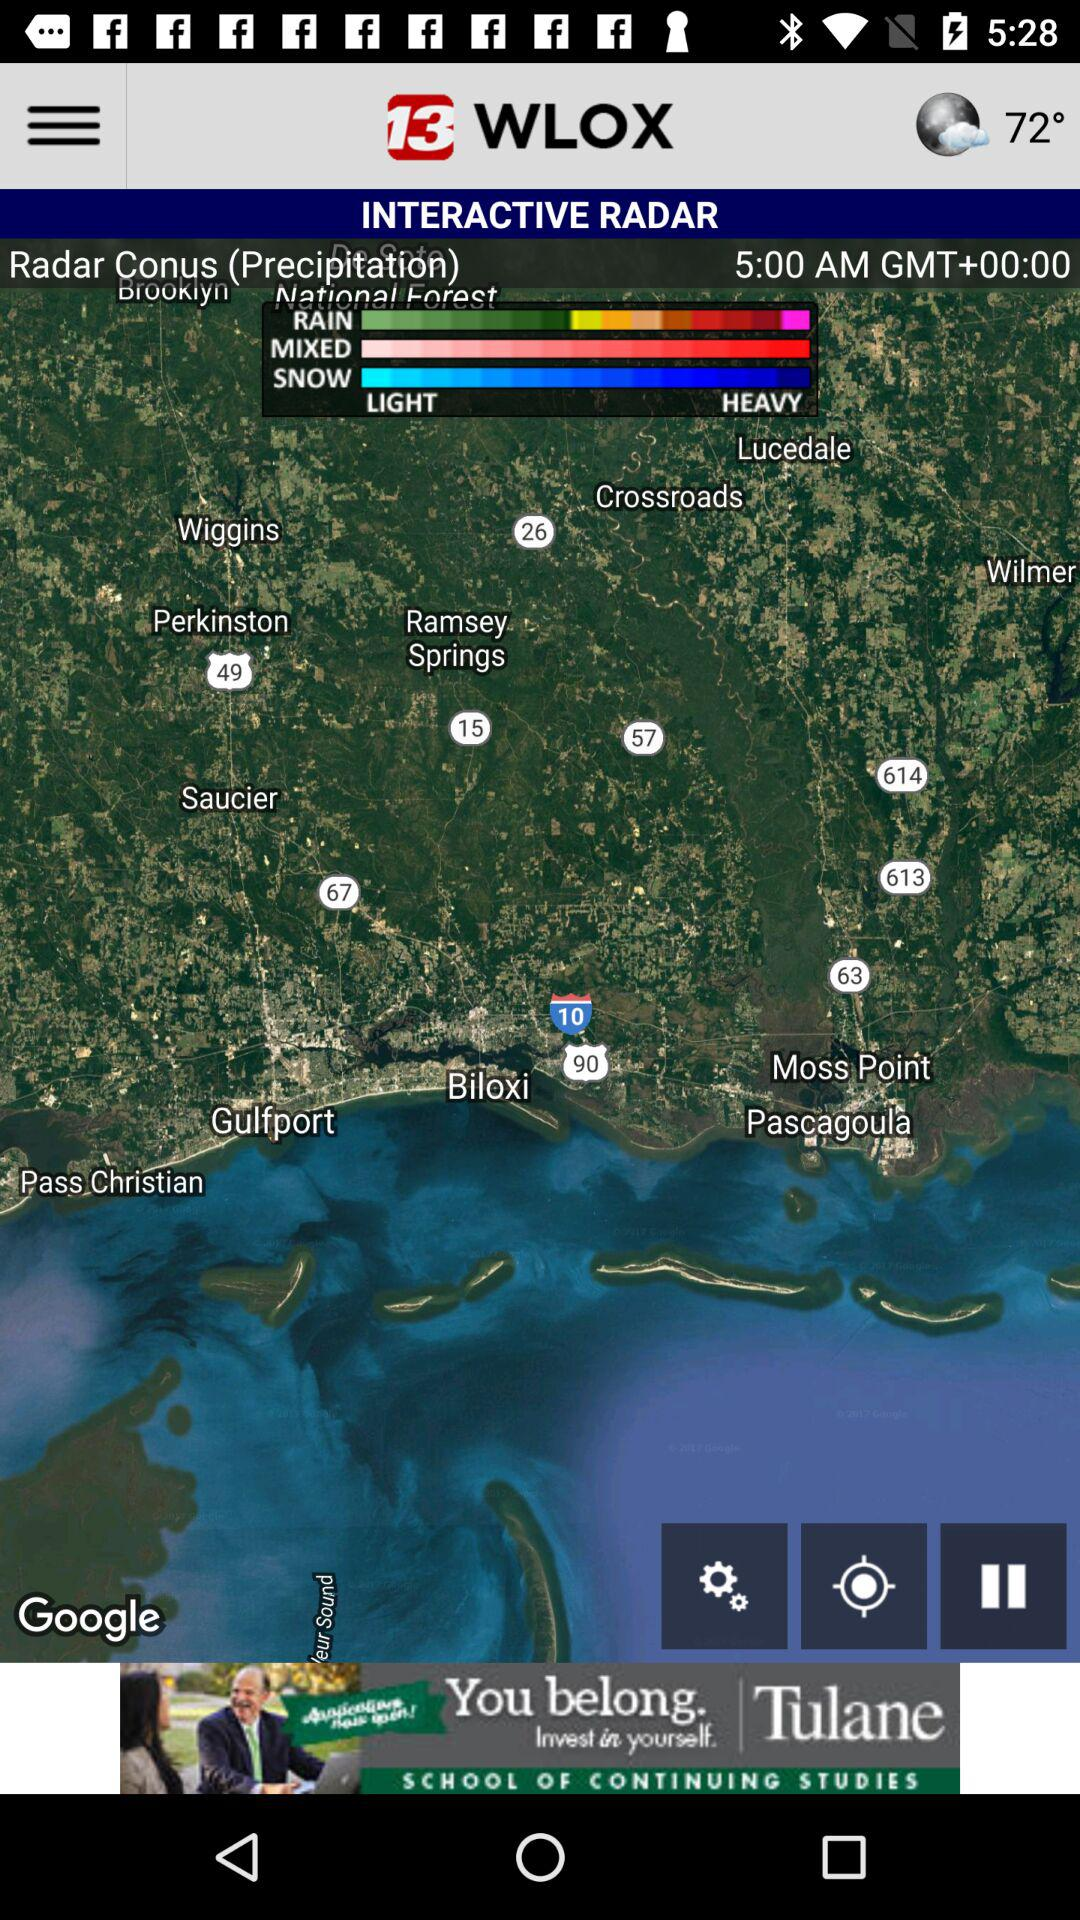At what time is precipitation data recorded? It is recorded at 5:00 AM in the Greenwich Mean Time. 